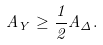Convert formula to latex. <formula><loc_0><loc_0><loc_500><loc_500>A _ { Y } \geq \frac { 1 } { 2 } A _ { \Delta } .</formula> 